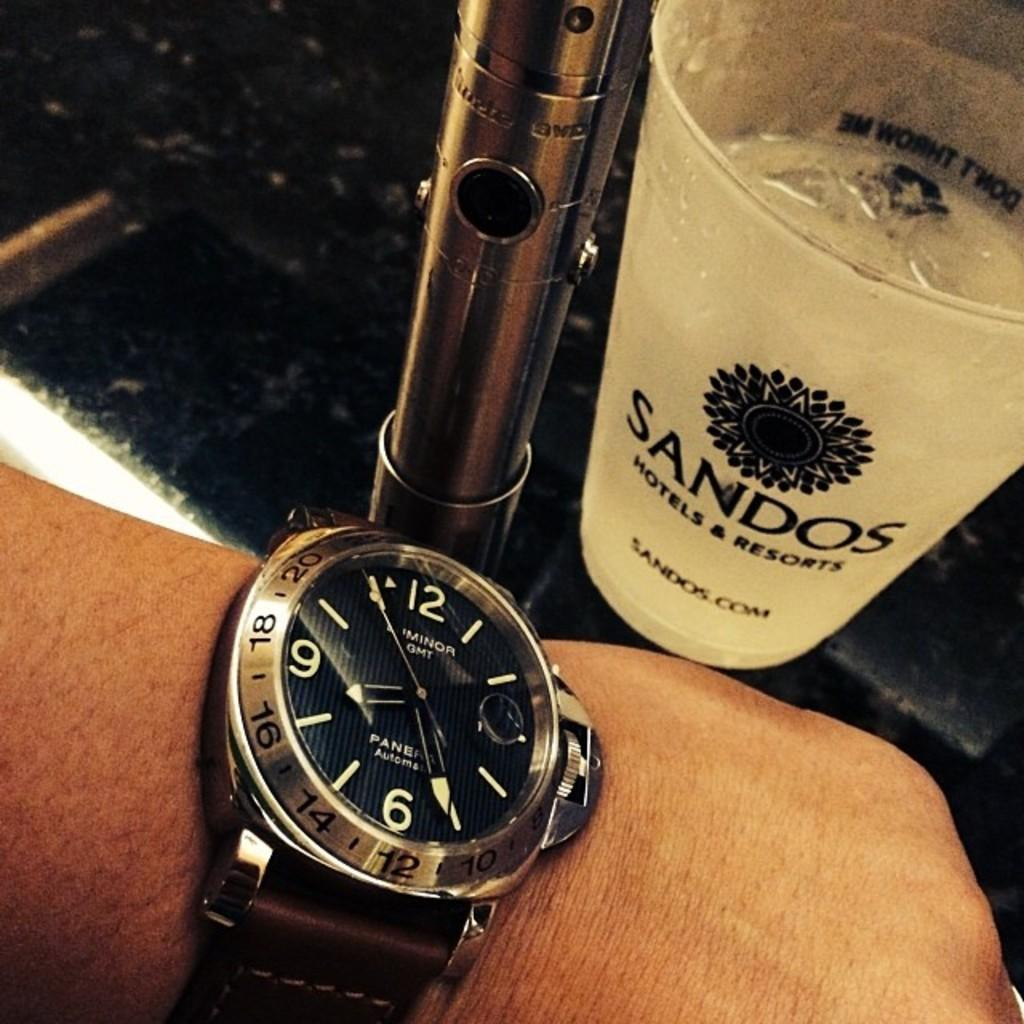What can be seen on the person's hand in the image? There is a watch on the person's hand in the image. What is in the glass that is visible in the image? There is liquid in the glass in the image. What is located in the right corner of the image? There is an object in the right corner of the image. What is visible beneath the objects in the image? The ground is visible in the image. What type of pencil can be seen in the image? There is no pencil present in the image. What kind of bushes are growing in the right corner of the image? There are no bushes visible in the image; only an object is present in the right corner. 